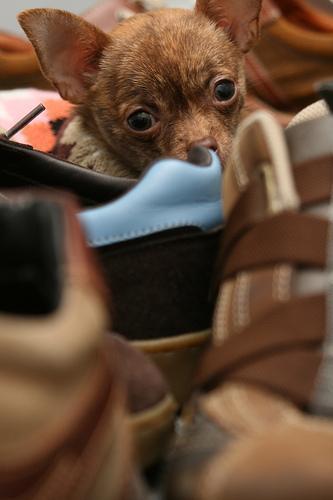How many of the dog's ears are completely shown?
Give a very brief answer. 1. How many of the dog's eyes are shown?
Give a very brief answer. 2. 